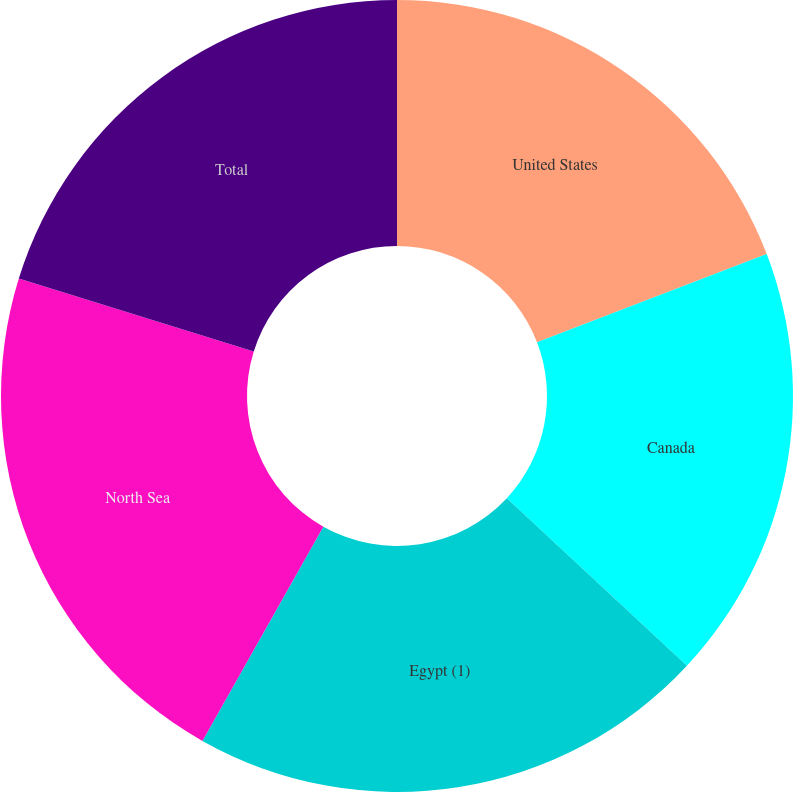Convert chart. <chart><loc_0><loc_0><loc_500><loc_500><pie_chart><fcel>United States<fcel>Canada<fcel>Egypt (1)<fcel>North Sea<fcel>Total<nl><fcel>19.17%<fcel>17.76%<fcel>21.25%<fcel>21.62%<fcel>20.21%<nl></chart> 